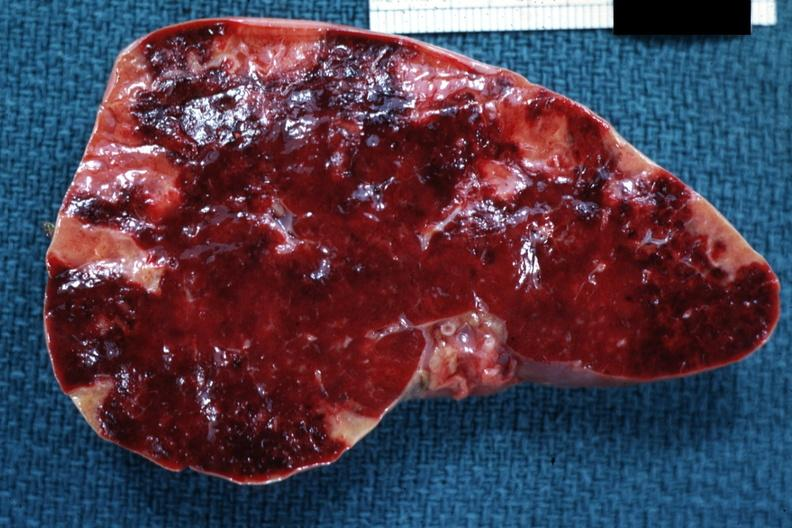s hematologic present?
Answer the question using a single word or phrase. Yes 